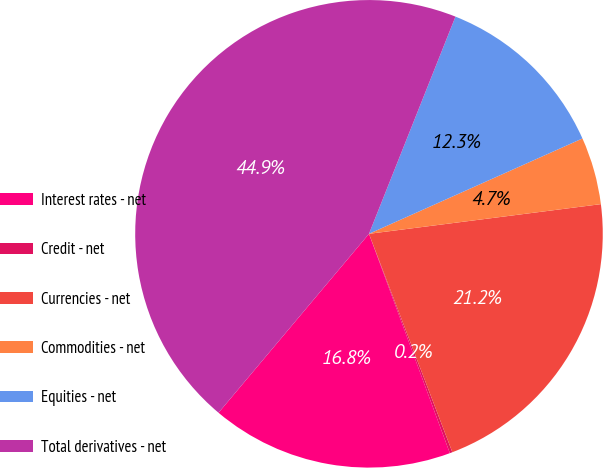Convert chart. <chart><loc_0><loc_0><loc_500><loc_500><pie_chart><fcel>Interest rates - net<fcel>Credit - net<fcel>Currencies - net<fcel>Commodities - net<fcel>Equities - net<fcel>Total derivatives - net<nl><fcel>16.75%<fcel>0.18%<fcel>21.22%<fcel>4.66%<fcel>12.28%<fcel>44.9%<nl></chart> 